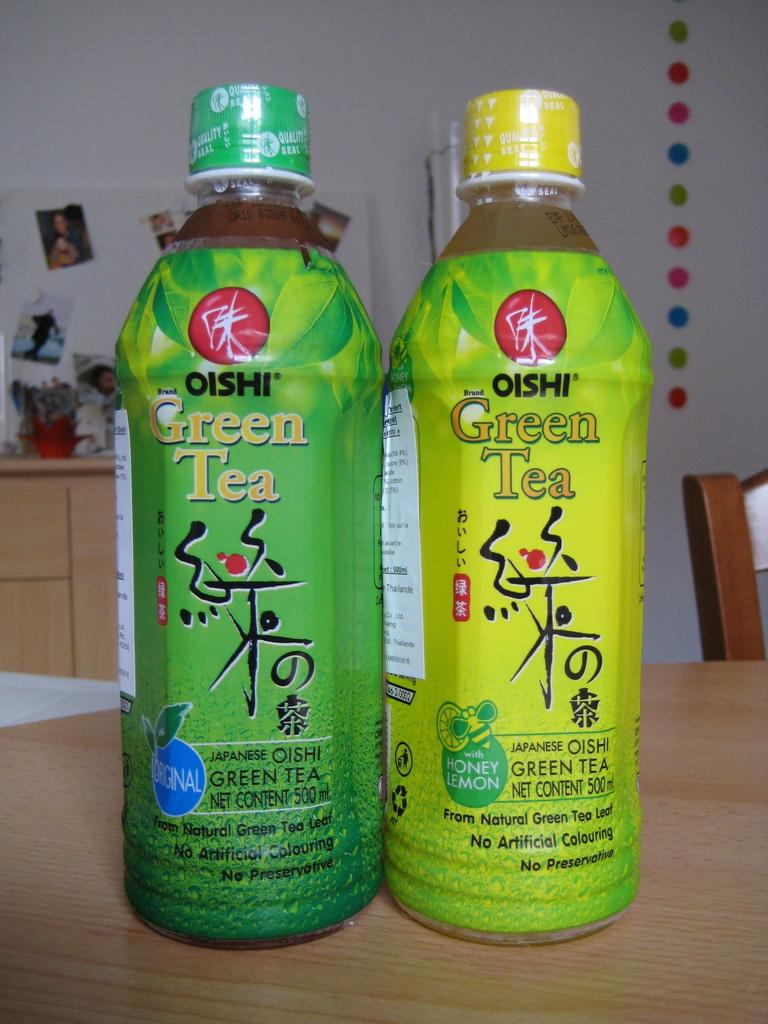<image>
Describe the image concisely. A bottle of original green tea sits next to a bottle of honey lemon green tea. 